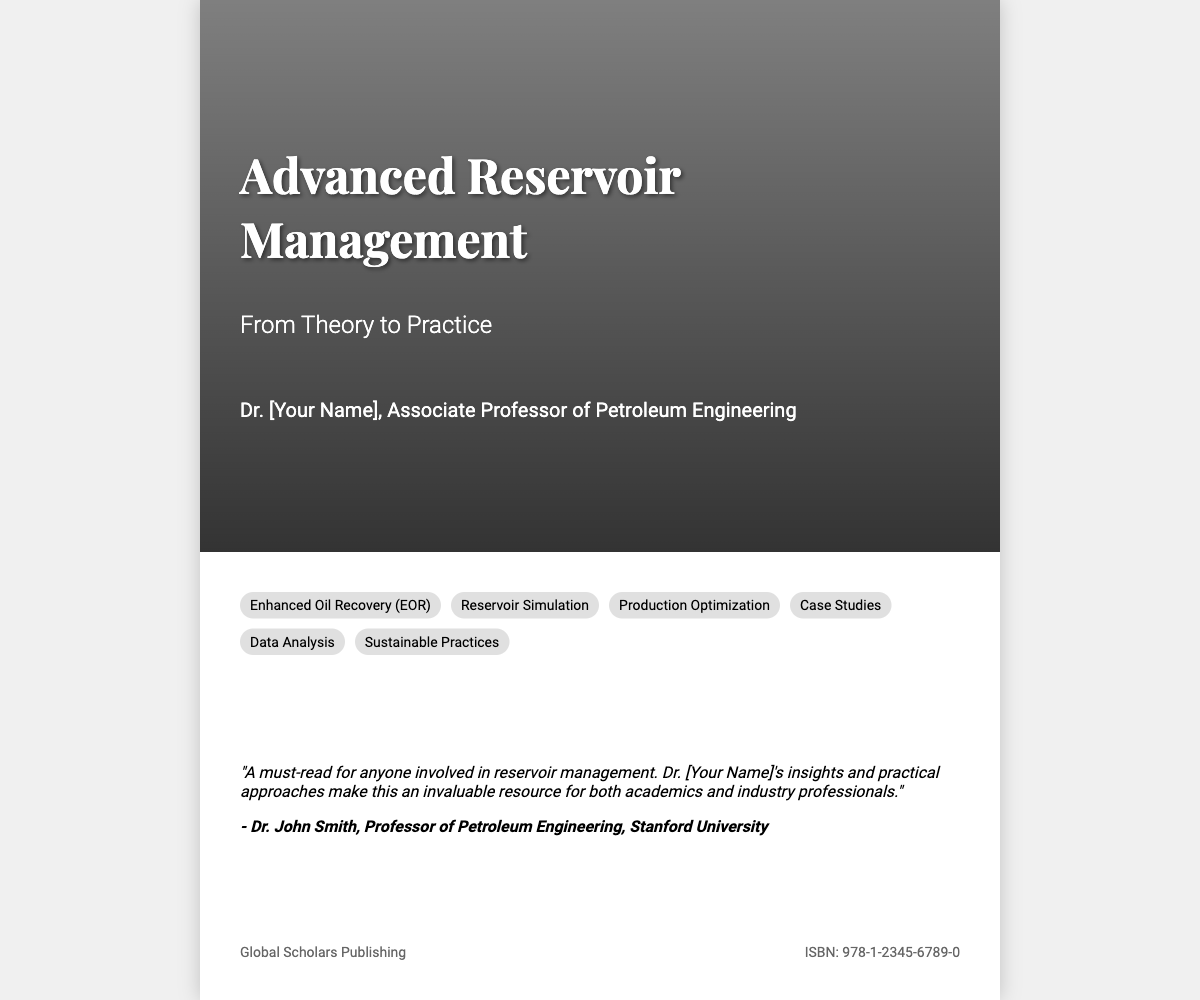What is the title of the book? The title of the book is prominently displayed on the cover, which is "Advanced Reservoir Management."
Answer: Advanced Reservoir Management What is the subtitle of the book? The subtitle of the book provides additional context and is stated as "From Theory to Practice."
Answer: From Theory to Practice Who is the author of the book? The author is identified on the cover as Dr. [Your Name], who holds a position as an Associate Professor of Petroleum Engineering.
Answer: Dr. [Your Name] Which publishing company published the book? The publisher's name is provided at the bottom of the cover as "Global Scholars Publishing."
Answer: Global Scholars Publishing What is the ISBN number listed on the cover? The ISBN number is a unique identifier for the book, which is displayed at the bottom as "978-1-2345-6789-0."
Answer: 978-1-2345-6789-0 What topic is related to sustainable practices in the book? The cover lists various relevant topics, and "Sustainable Practices" is one of them.
Answer: Sustainable Practices Who endorsed the book? The endorsement section includes a quote from a specific individual, which is "Dr. John Smith."
Answer: Dr. John Smith What field does the author specialize in? The author’s specialization is highlighted in the title, indicating a focus on petroleum engineering.
Answer: Petroleum Engineering How many topics are listed on the cover? The enumeration of topics visible on the cover reveals there are six listed topics.
Answer: Six 